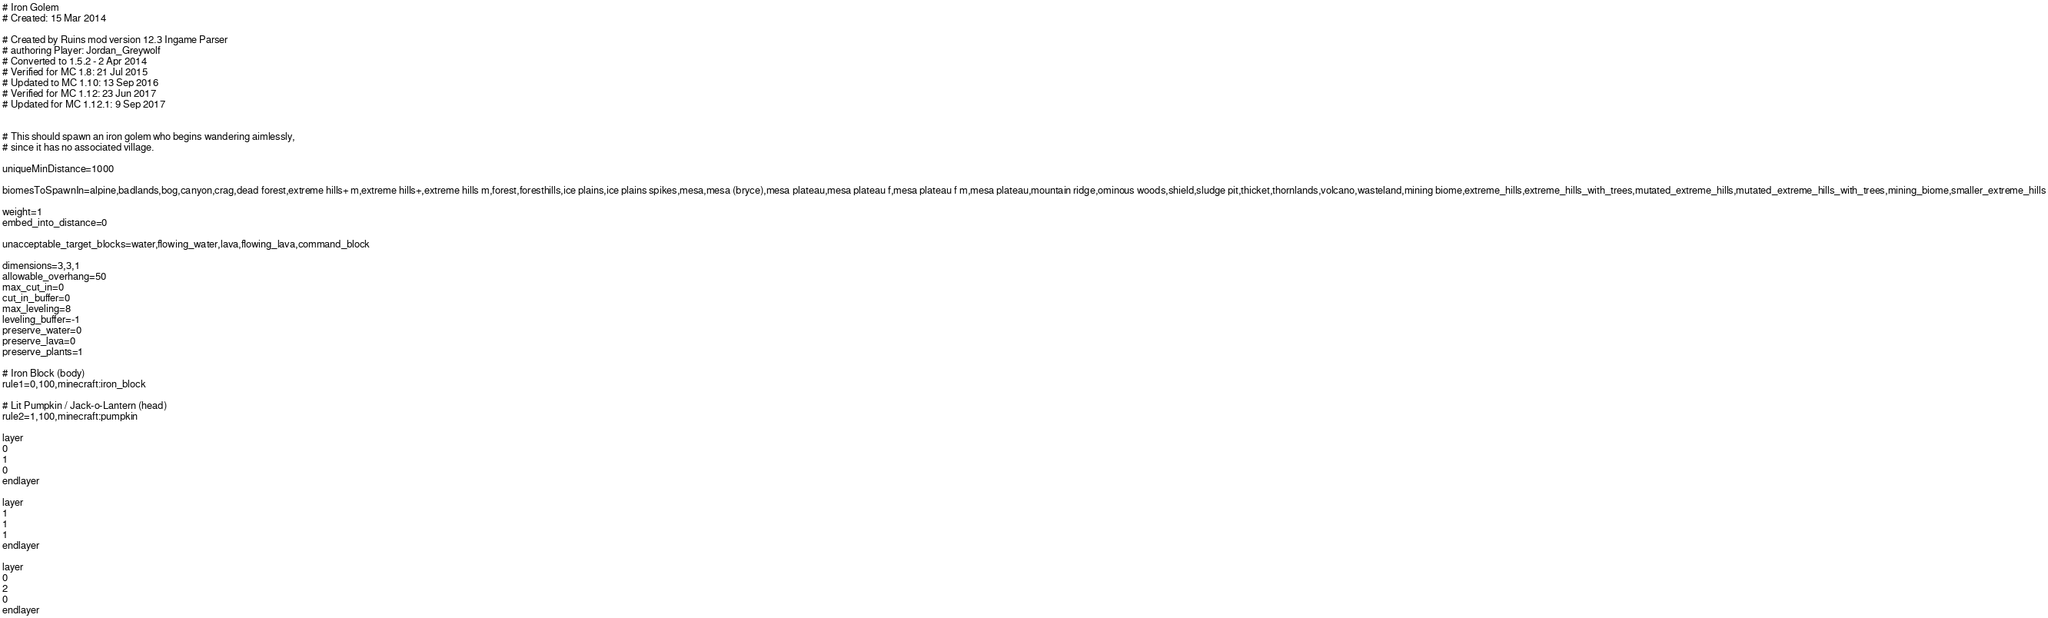<code> <loc_0><loc_0><loc_500><loc_500><_XML_>
# Iron Golem
# Created: 15 Mar 2014

# Created by Ruins mod version 12.3 Ingame Parser
# authoring Player: Jordan_Greywolf
# Converted to 1.5.2 - 2 Apr 2014
# Verified for MC 1.8: 21 Jul 2015
# Updated to MC 1.10: 13 Sep 2016
# Verified for MC 1.12: 23 Jun 2017
# Updated for MC 1.12.1: 9 Sep 2017


# This should spawn an iron golem who begins wandering aimlessly,
# since it has no associated village.

uniqueMinDistance=1000

biomesToSpawnIn=alpine,badlands,bog,canyon,crag,dead forest,extreme hills+ m,extreme hills+,extreme hills m,forest,foresthills,ice plains,ice plains spikes,mesa,mesa (bryce),mesa plateau,mesa plateau f,mesa plateau f m,mesa plateau,mountain ridge,ominous woods,shield,sludge pit,thicket,thornlands,volcano,wasteland,mining biome,extreme_hills,extreme_hills_with_trees,mutated_extreme_hills,mutated_extreme_hills_with_trees,mining_biome,smaller_extreme_hills

weight=1
embed_into_distance=0

unacceptable_target_blocks=water,flowing_water,lava,flowing_lava,command_block

dimensions=3,3,1
allowable_overhang=50
max_cut_in=0
cut_in_buffer=0
max_leveling=8
leveling_buffer=-1
preserve_water=0
preserve_lava=0
preserve_plants=1

# Iron Block (body)
rule1=0,100,minecraft:iron_block

# Lit Pumpkin / Jack-o-Lantern (head)
rule2=1,100,minecraft:pumpkin

layer
0
1
0
endlayer

layer
1
1
1
endlayer

layer
0
2
0
endlayer

</code> 